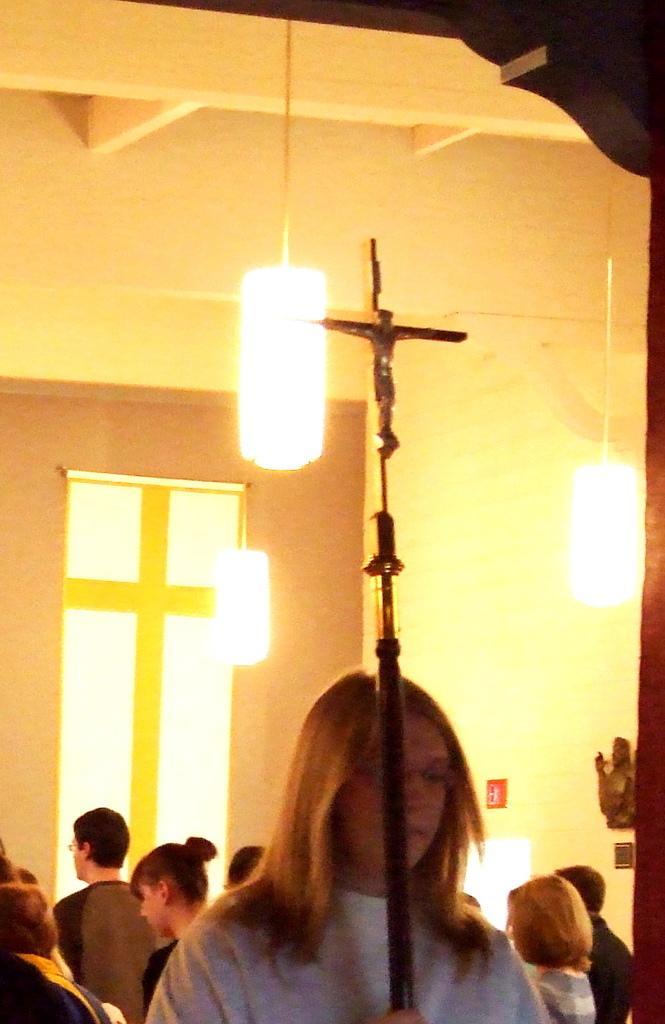Could you give a brief overview of what you see in this image? In this image in the foreground a woman holding a pole, on which cross is attached, in the background there is the wall and in front of the wall there is a door, there are some lights are hanging on the wall. 